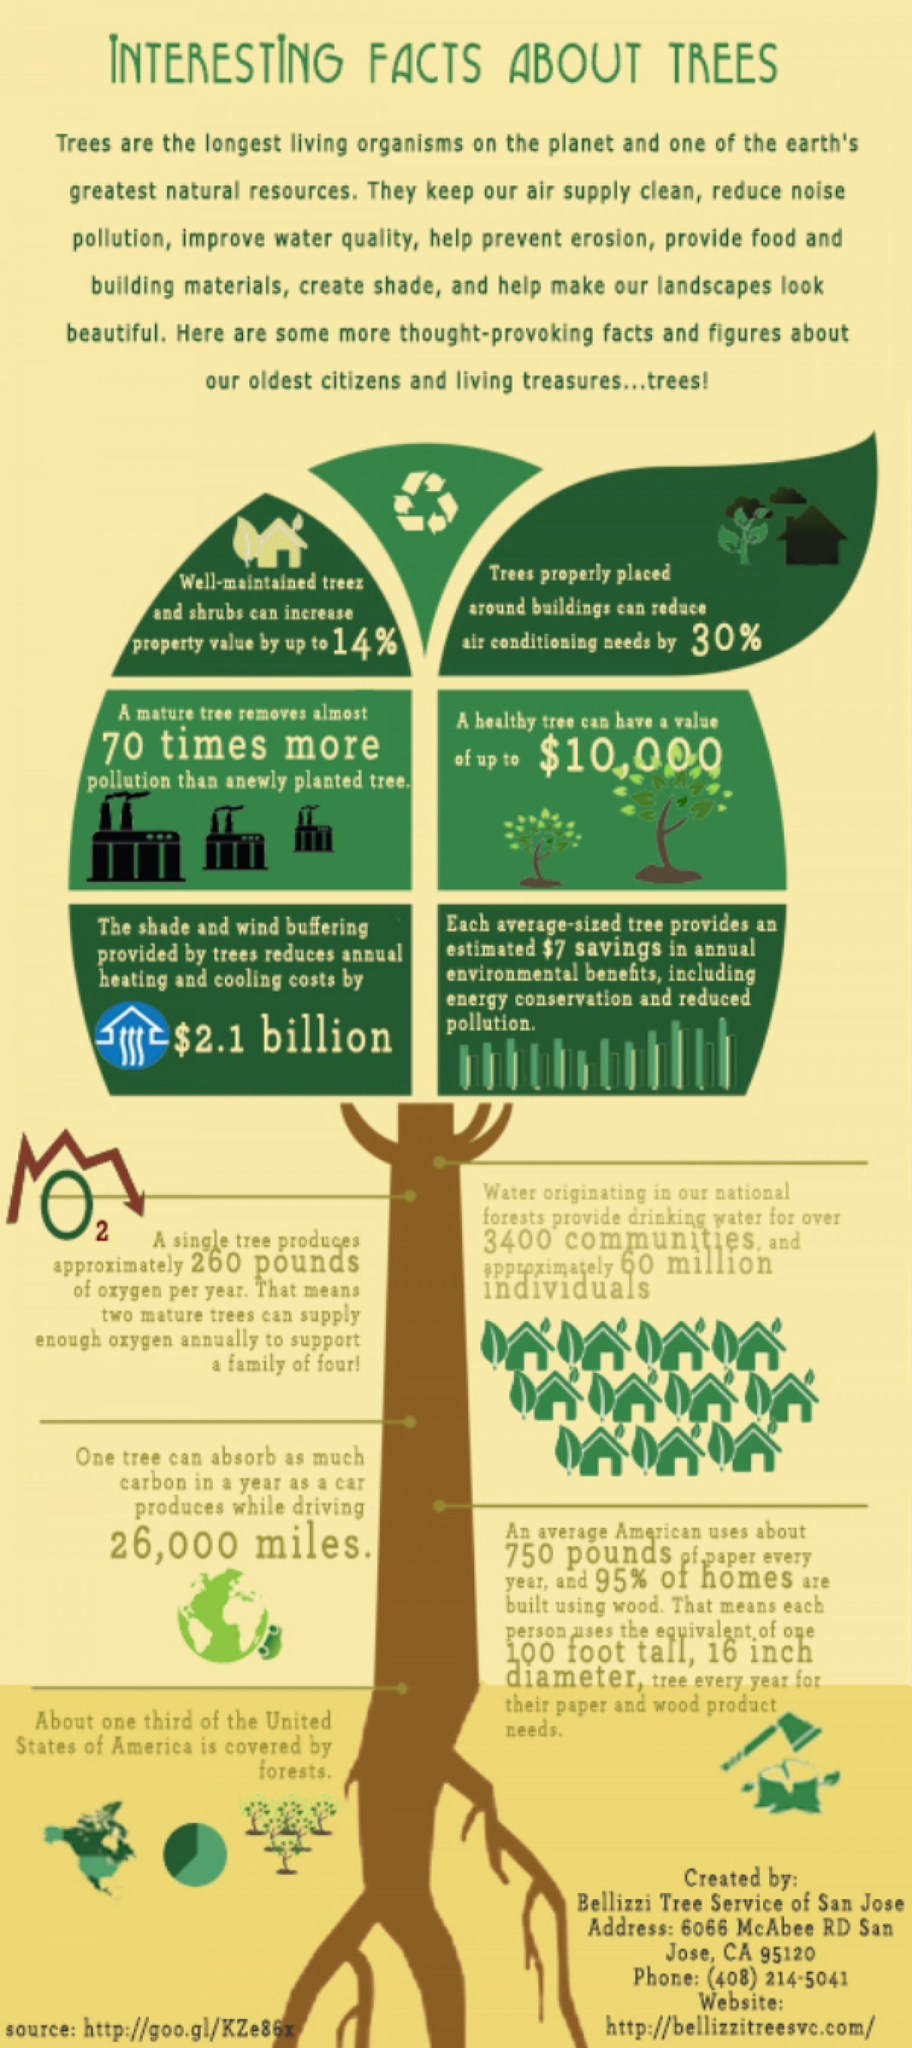What is the percentage reduction in cooling appliances due to trees, 14%, 30%, or 95%?
Answer the question with a short phrase. 30% 